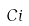<formula> <loc_0><loc_0><loc_500><loc_500>C i</formula> 